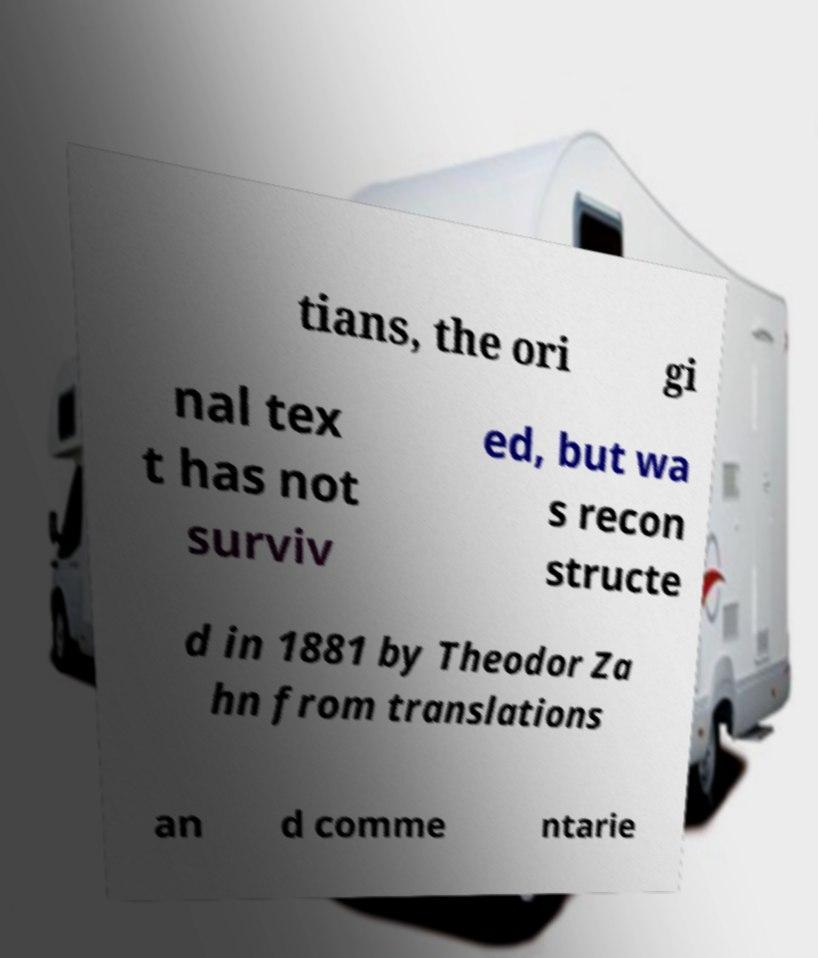I need the written content from this picture converted into text. Can you do that? tians, the ori gi nal tex t has not surviv ed, but wa s recon structe d in 1881 by Theodor Za hn from translations an d comme ntarie 